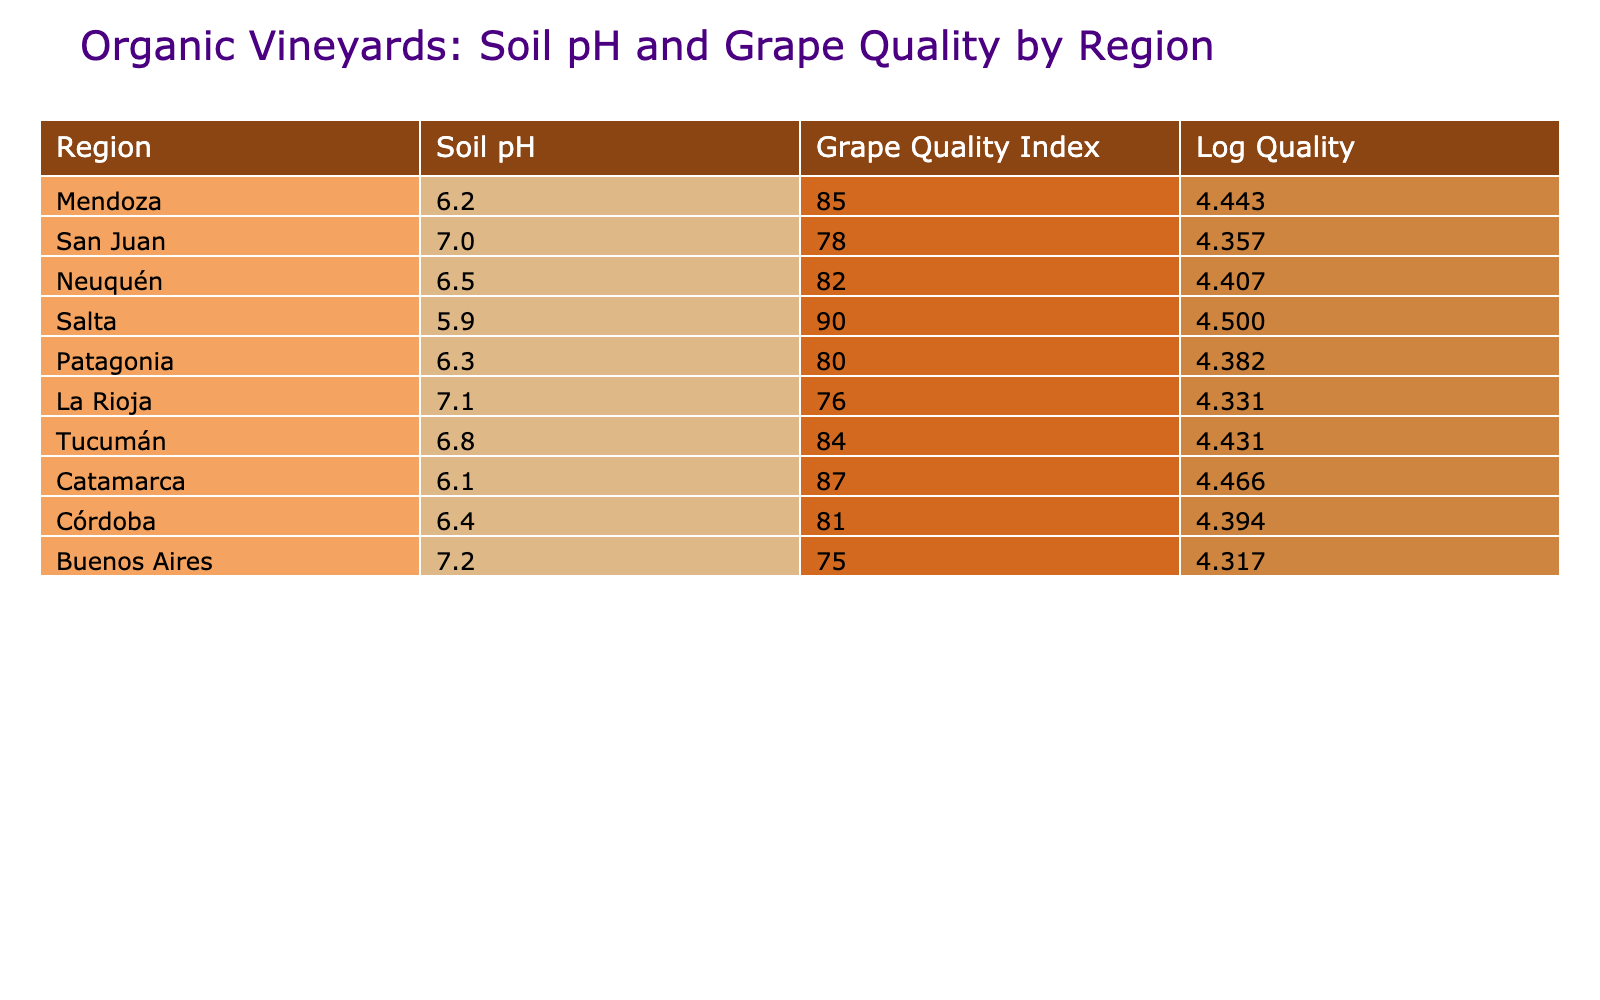What is the soil pH level of the region with the highest grape quality index? According to the table, Salta has the highest grape quality index at 90 with a soil pH of 5.9.
Answer: 5.9 What is the grape quality index for Mendoza? The grape quality index for Mendoza is listed in the table as 85.
Answer: 85 Which region has the lowest grape quality index? Looking at the table, Buenos Aires has the lowest grape quality index at 75.
Answer: 75 What is the average pH level of the listed regions? First, add up all the pH values: 6.2 + 7.0 + 6.5 + 5.9 + 6.3 + 7.1 + 6.8 + 6.1 + 6.4 + 7.2 = 66.2. Then divide by the number of regions (10): 66.2 / 10 = 6.62.
Answer: 6.62 Is there a region with a grape quality index higher than 85 that also has a pH level of less than 6.5? The table indicates that Salta has a quality index of 90 with a pH of 5.9, which satisfies both conditions. Thus, the answer is yes.
Answer: Yes What is the difference in grape quality index between the highest and lowest regions? The highest grape quality index is 90 (Salta) and the lowest is 75 (Buenos Aires). The difference is 90 - 75 = 15.
Answer: 15 Which region has a pH greater than 7 and what is its grape quality index? From the table, Buenos Aires and La Rioja are both listed with a pH greater than 7. Buenos Aires has an index of 75, and La Rioja has an index of 76.
Answer: Buenos Aires (75) and La Rioja (76) Is the grape quality index for Neuquén greater than 80? The table shows that Neuquén has a grape quality index of 82, which is indeed greater than 80.
Answer: Yes Which regions have a pH below 6.5, and what are their grape quality indices? The regions with pH below 6.5 are Salta (pH 5.9, index 90), Mendoza (pH 6.2, index 85), and Catamarca (pH 6.1, index 87).
Answer: Salta (90), Mendoza (85), Catamarca (87) 